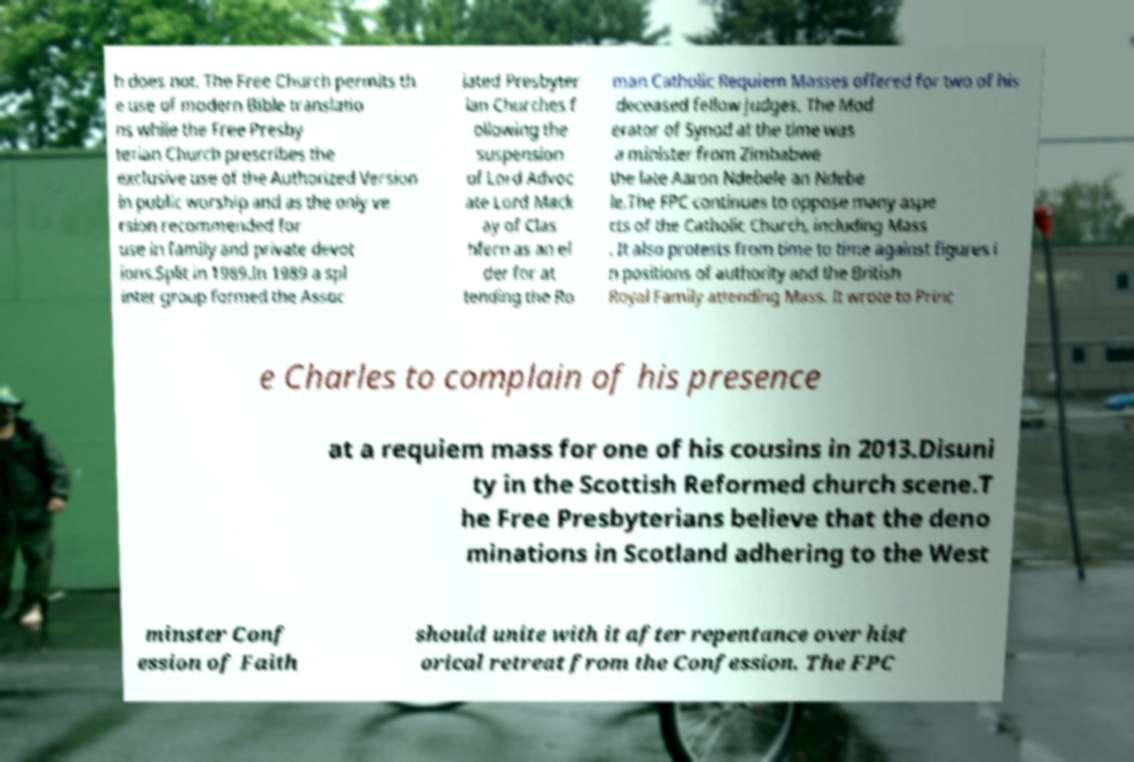I need the written content from this picture converted into text. Can you do that? h does not. The Free Church permits th e use of modern Bible translatio ns while the Free Presby terian Church prescribes the exclusive use of the Authorized Version in public worship and as the only ve rsion recommended for use in family and private devot ions.Split in 1989.In 1989 a spl inter group formed the Assoc iated Presbyter ian Churches f ollowing the suspension of Lord Advoc ate Lord Mack ay of Clas hfern as an el der for at tending the Ro man Catholic Requiem Masses offered for two of his deceased fellow judges. The Mod erator of Synod at the time was a minister from Zimbabwe the late Aaron Ndebele an Ndebe le.The FPC continues to oppose many aspe cts of the Catholic Church, including Mass . It also protests from time to time against figures i n positions of authority and the British Royal Family attending Mass. It wrote to Princ e Charles to complain of his presence at a requiem mass for one of his cousins in 2013.Disuni ty in the Scottish Reformed church scene.T he Free Presbyterians believe that the deno minations in Scotland adhering to the West minster Conf ession of Faith should unite with it after repentance over hist orical retreat from the Confession. The FPC 